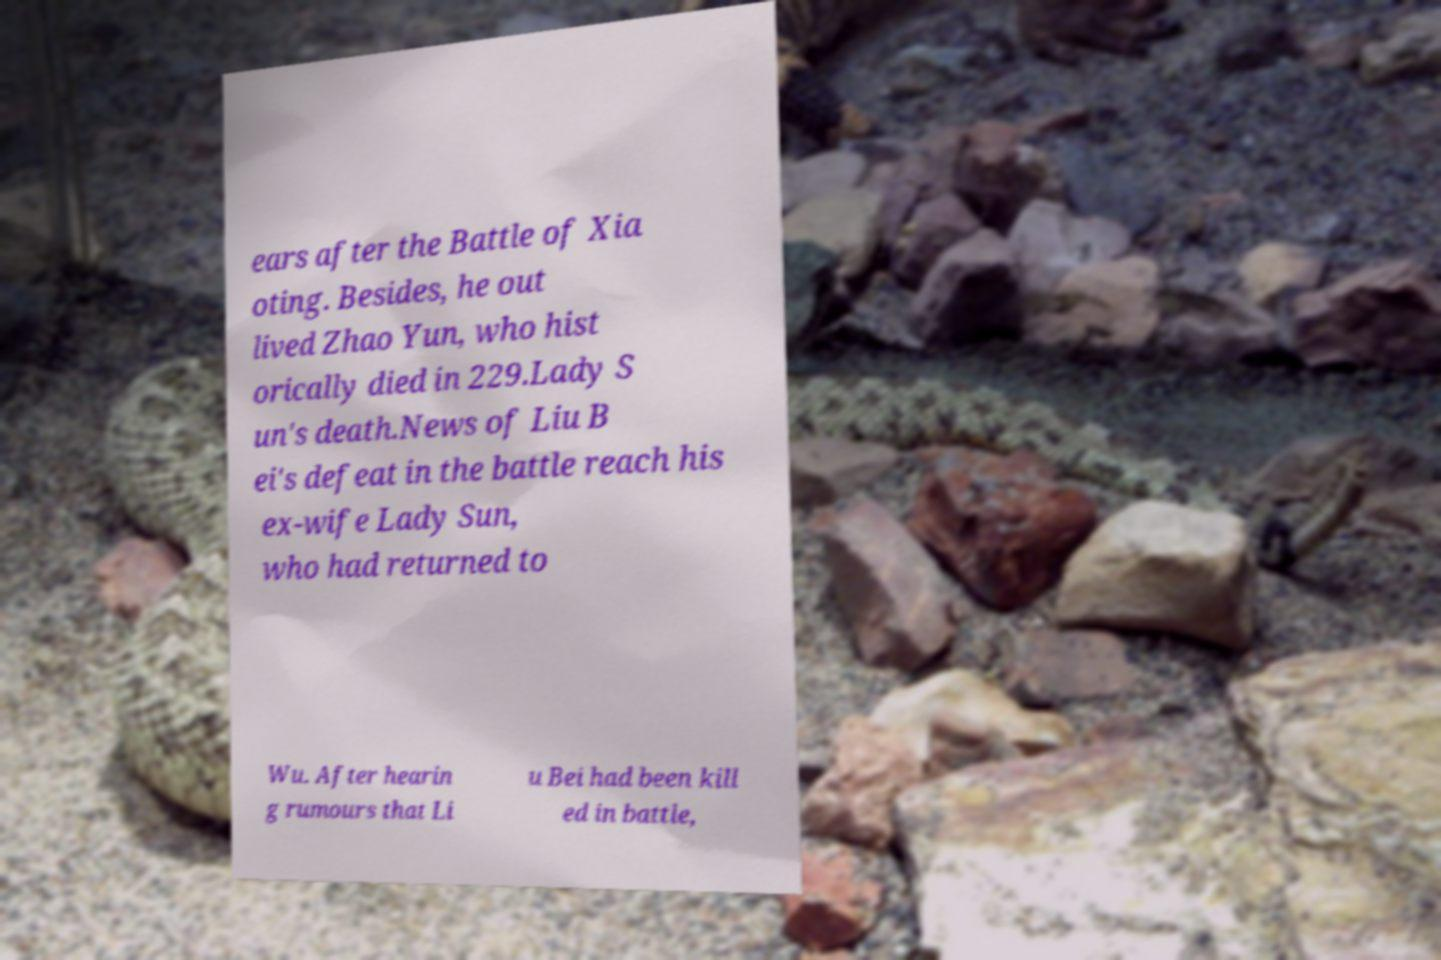Could you assist in decoding the text presented in this image and type it out clearly? ears after the Battle of Xia oting. Besides, he out lived Zhao Yun, who hist orically died in 229.Lady S un's death.News of Liu B ei's defeat in the battle reach his ex-wife Lady Sun, who had returned to Wu. After hearin g rumours that Li u Bei had been kill ed in battle, 